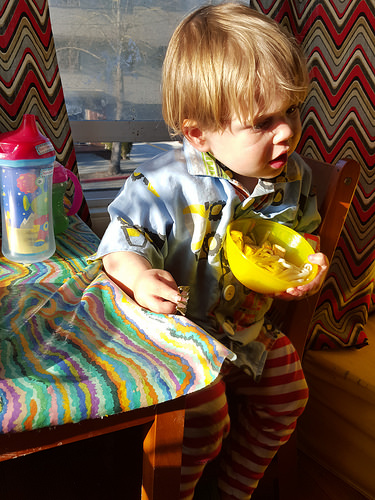<image>
Can you confirm if the boy is on the blanket? Yes. Looking at the image, I can see the boy is positioned on top of the blanket, with the blanket providing support. 